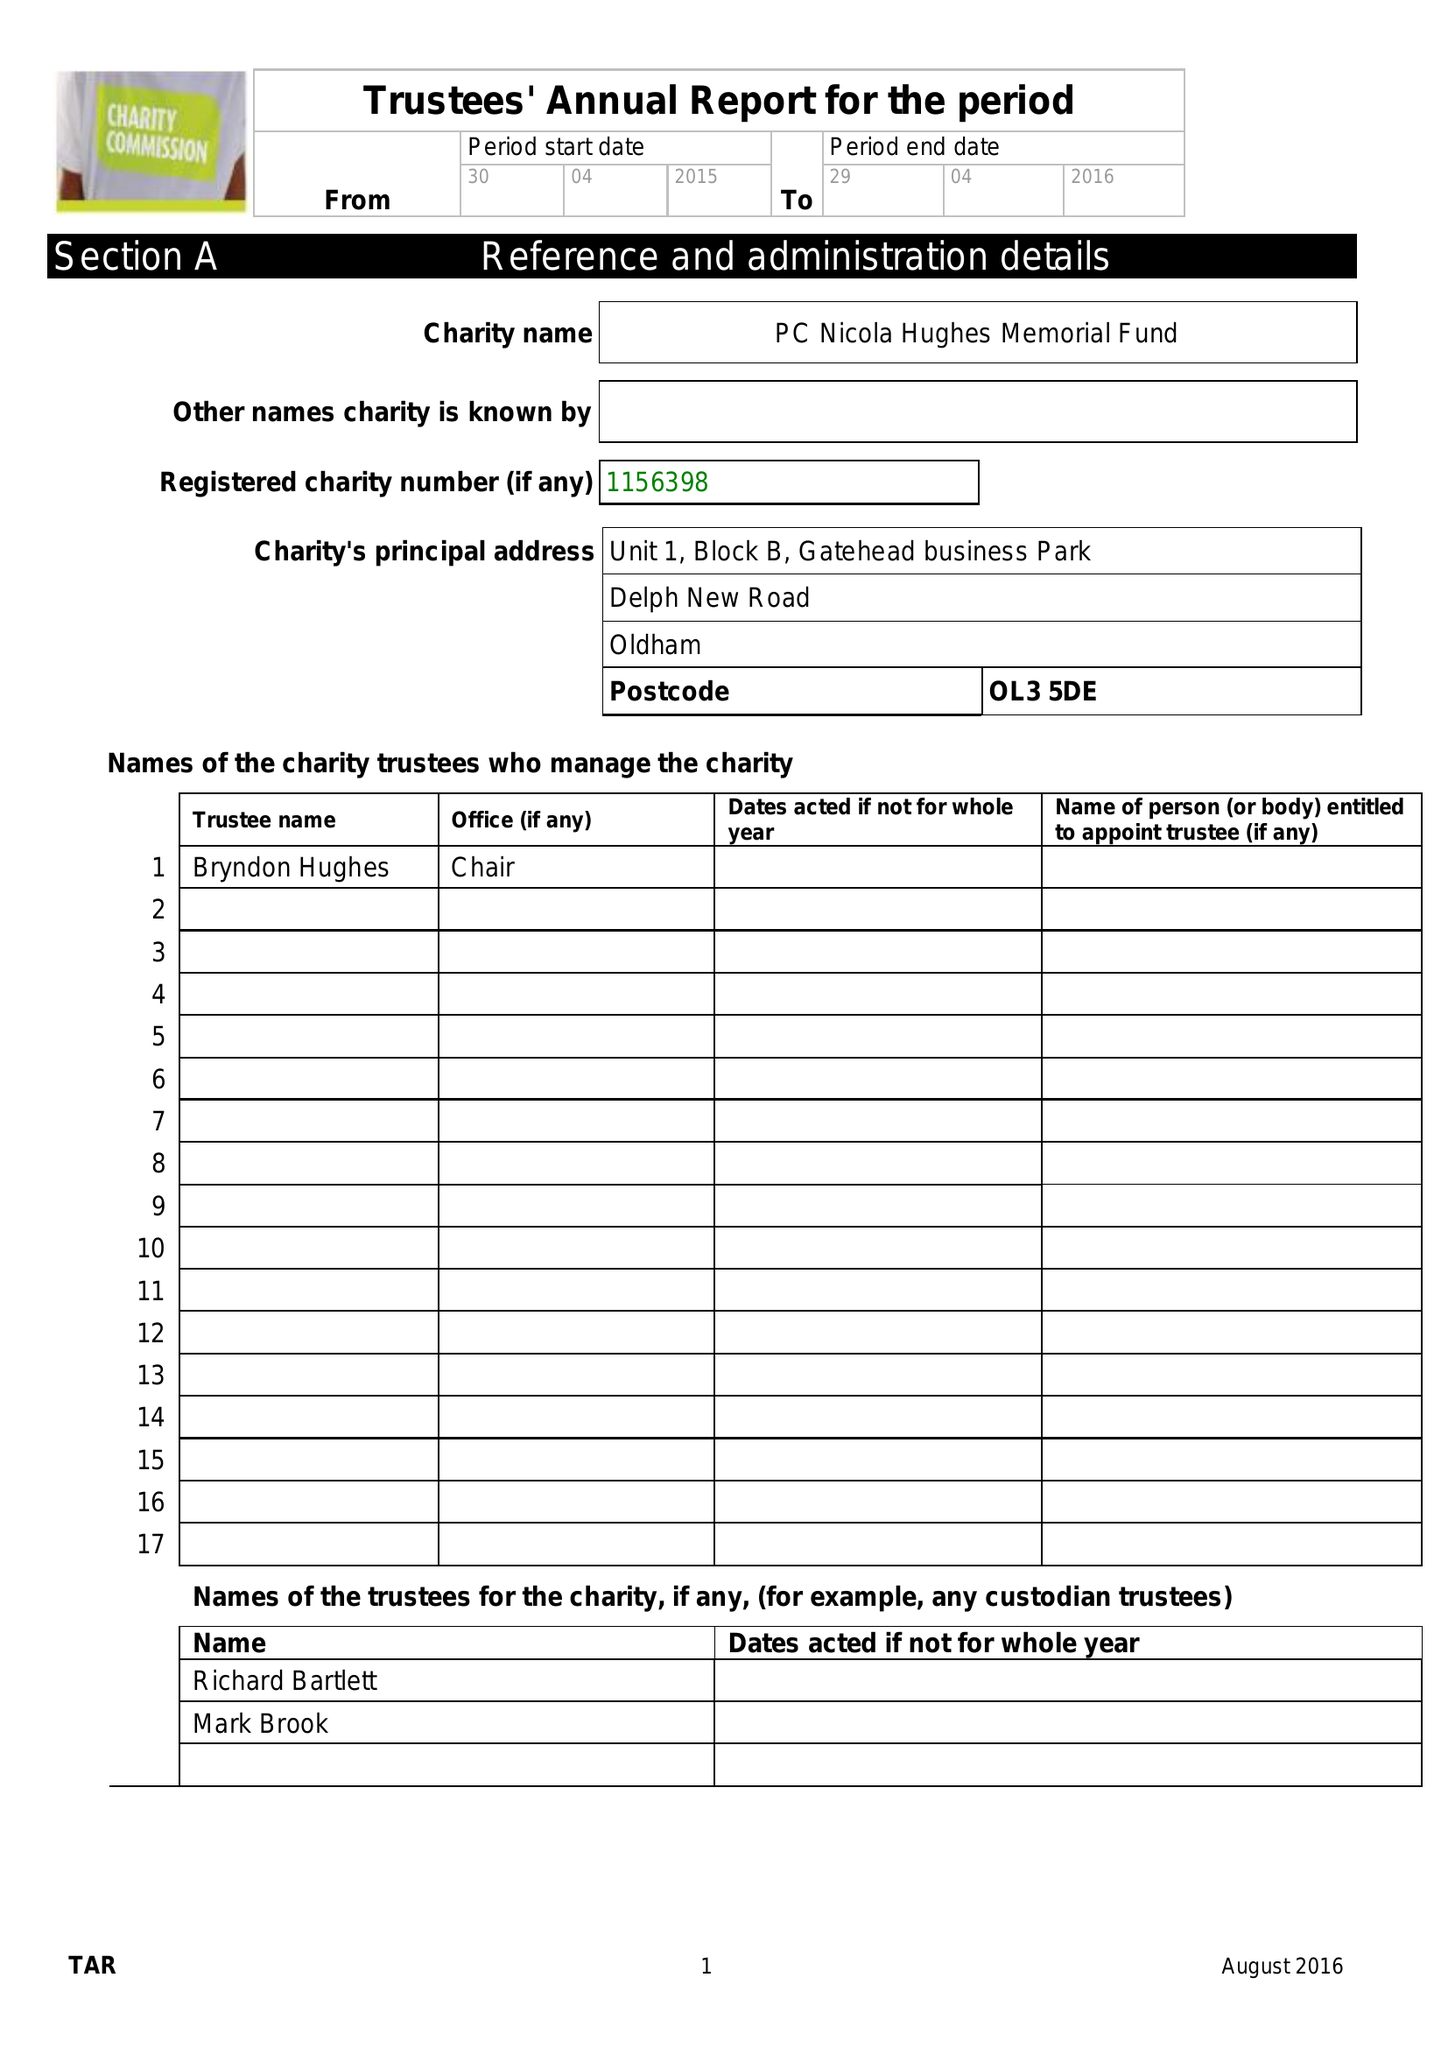What is the value for the address__post_town?
Answer the question using a single word or phrase. OLDHAM 